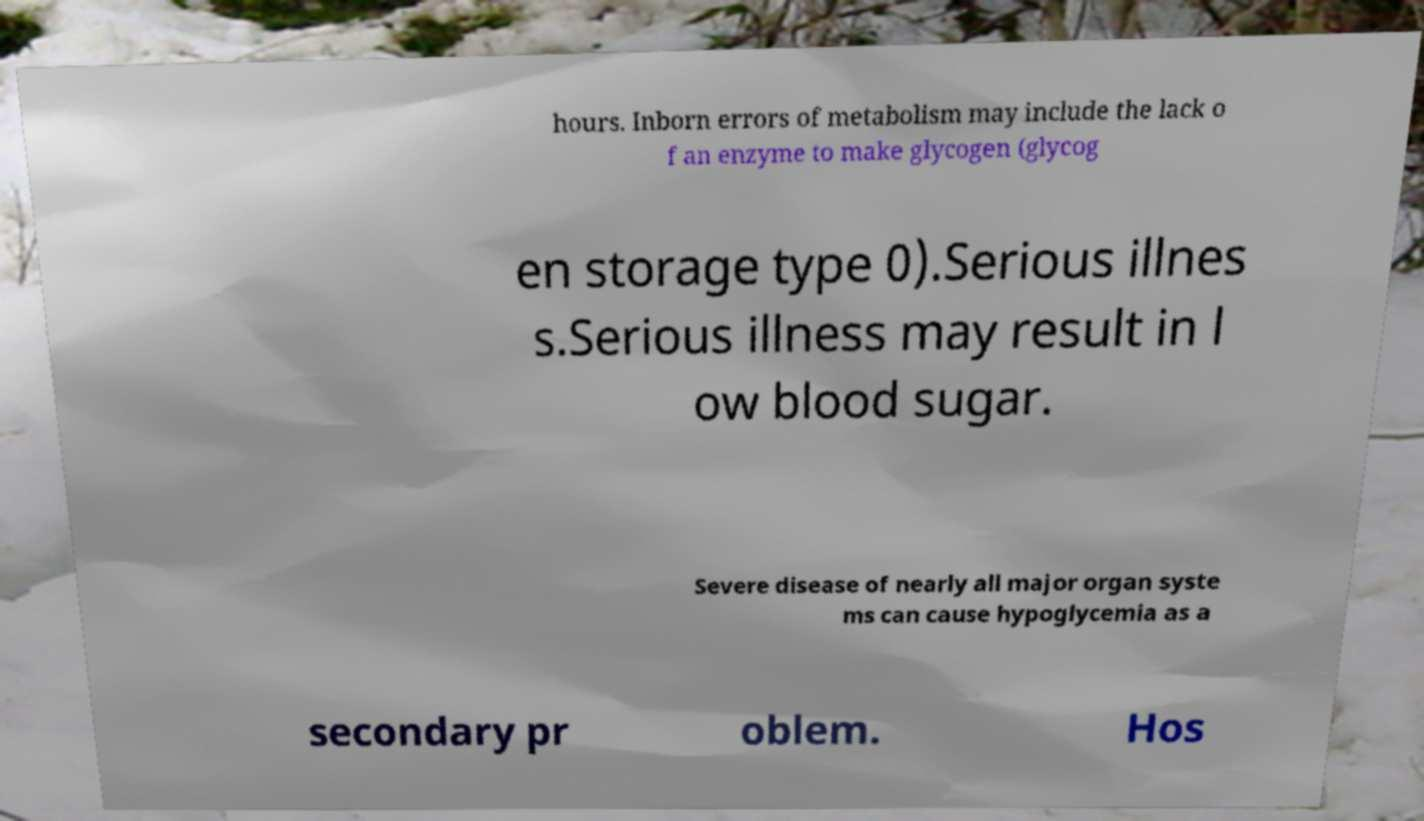For documentation purposes, I need the text within this image transcribed. Could you provide that? hours. Inborn errors of metabolism may include the lack o f an enzyme to make glycogen (glycog en storage type 0).Serious illnes s.Serious illness may result in l ow blood sugar. Severe disease of nearly all major organ syste ms can cause hypoglycemia as a secondary pr oblem. Hos 